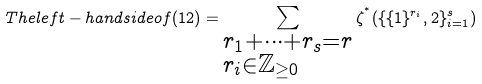<formula> <loc_0><loc_0><loc_500><loc_500>T h e l e f t - h a n d s i d e o f ( 1 2 ) = \sum _ { \begin{subarray} { c } r _ { 1 } + \cdots + r _ { s } = r \\ r _ { i } \in \mathbb { Z } _ { \geq 0 } \end{subarray} } \zeta ^ { ^ { * } } ( \{ \{ 1 \} ^ { r _ { i } } , 2 \} _ { i = 1 } ^ { s } )</formula> 